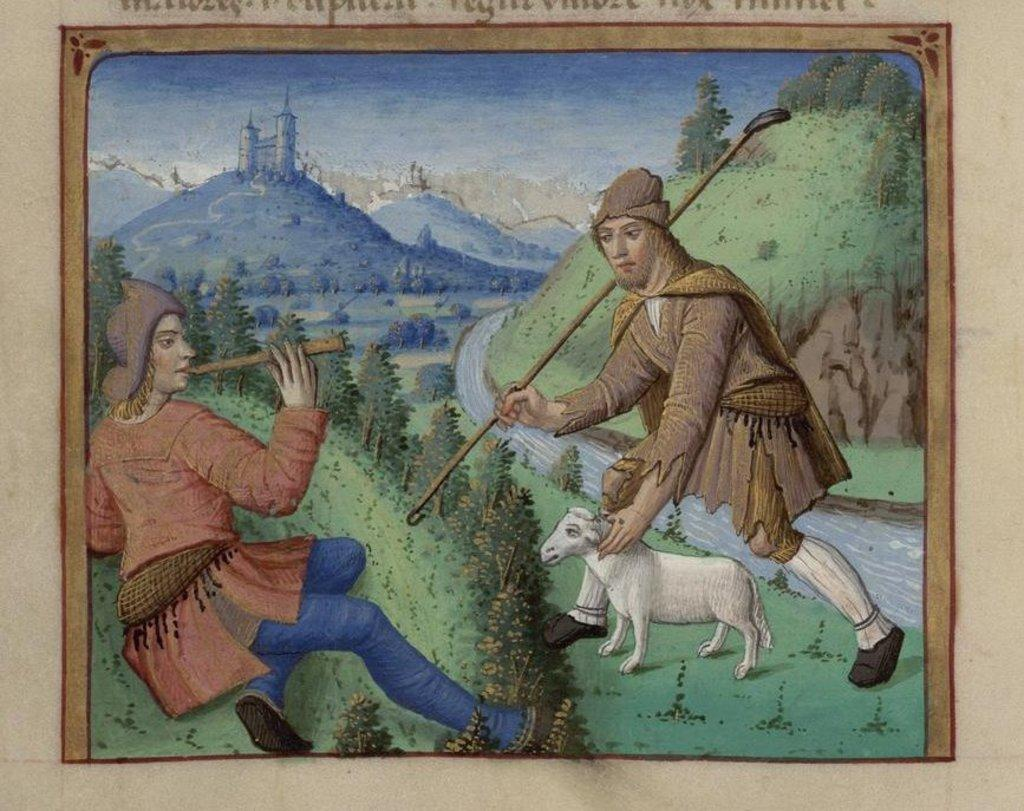What animals are depicted in the painting? The painting depicts sheep. What other subjects are depicted in the painting? The painting depicts people, mountains, trees, a fort, the sky, and water. Can you describe the landscape depicted in the painting? The painting depicts a landscape that includes mountains, trees, a fort, the sky, and water. How many friends are depicted in the painting? There are no friends explicitly depicted in the painting; it features sheep, people, mountains, trees, a fort, the sky, and water. 